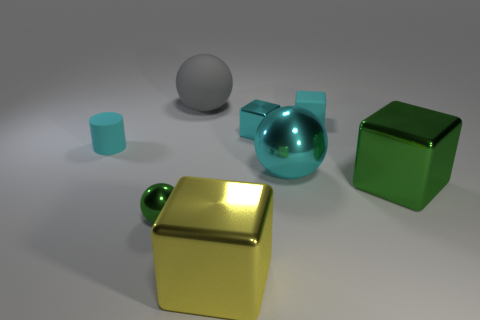Subtract 2 cubes. How many cubes are left? 2 Subtract all metallic cubes. How many cubes are left? 1 Add 1 big yellow blocks. How many objects exist? 9 Subtract all gray cubes. Subtract all gray cylinders. How many cubes are left? 4 Subtract all cylinders. How many objects are left? 7 Add 7 purple metal things. How many purple metal things exist? 7 Subtract 0 blue cylinders. How many objects are left? 8 Subtract all green blocks. Subtract all big yellow metallic cubes. How many objects are left? 6 Add 7 yellow metal blocks. How many yellow metal blocks are left? 8 